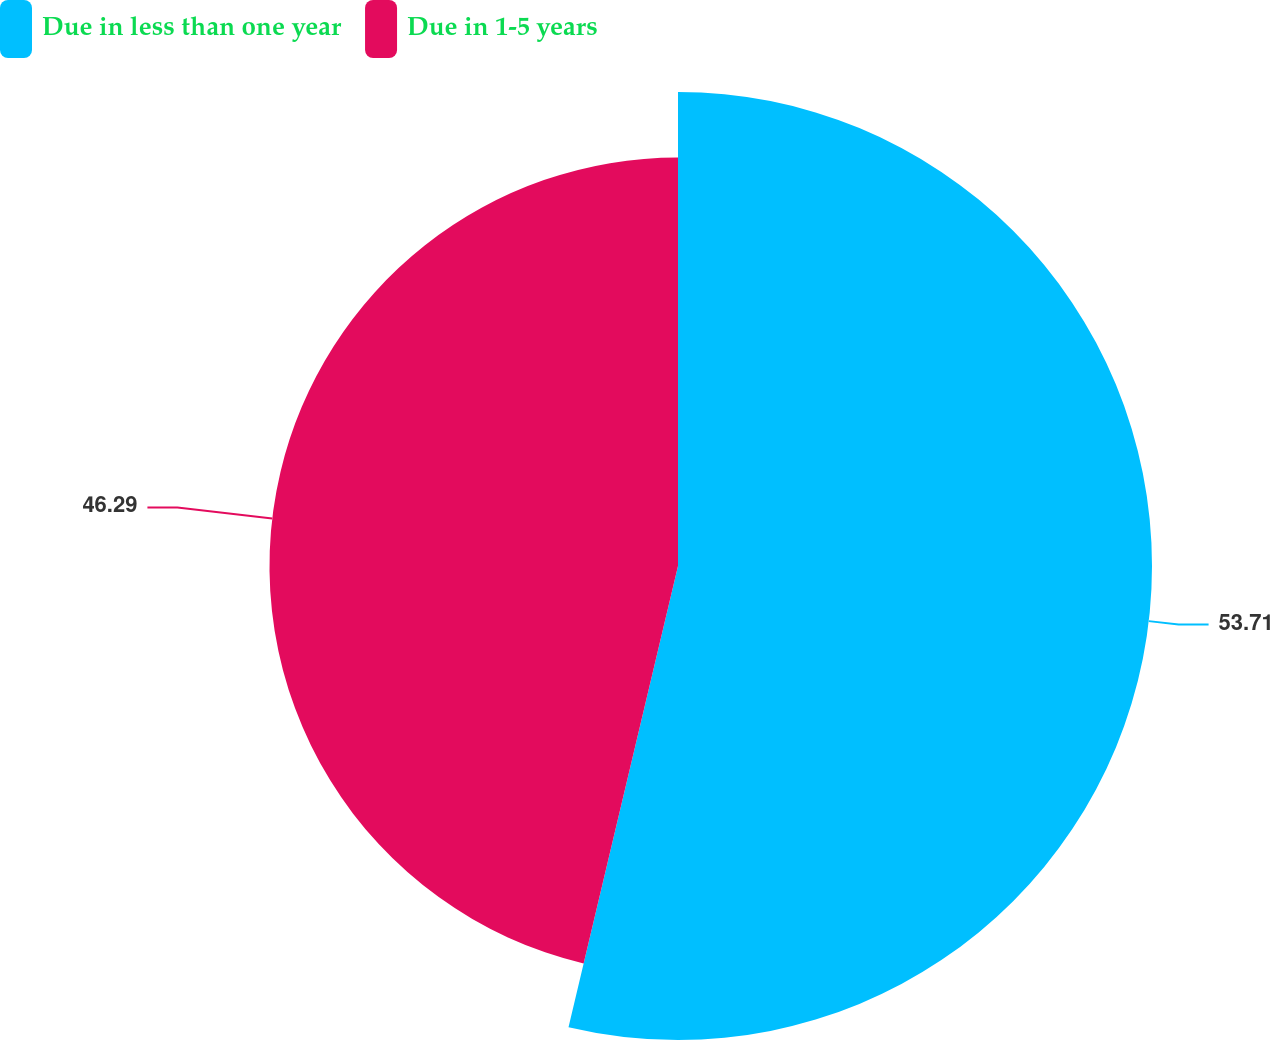<chart> <loc_0><loc_0><loc_500><loc_500><pie_chart><fcel>Due in less than one year<fcel>Due in 1-5 years<nl><fcel>53.71%<fcel>46.29%<nl></chart> 